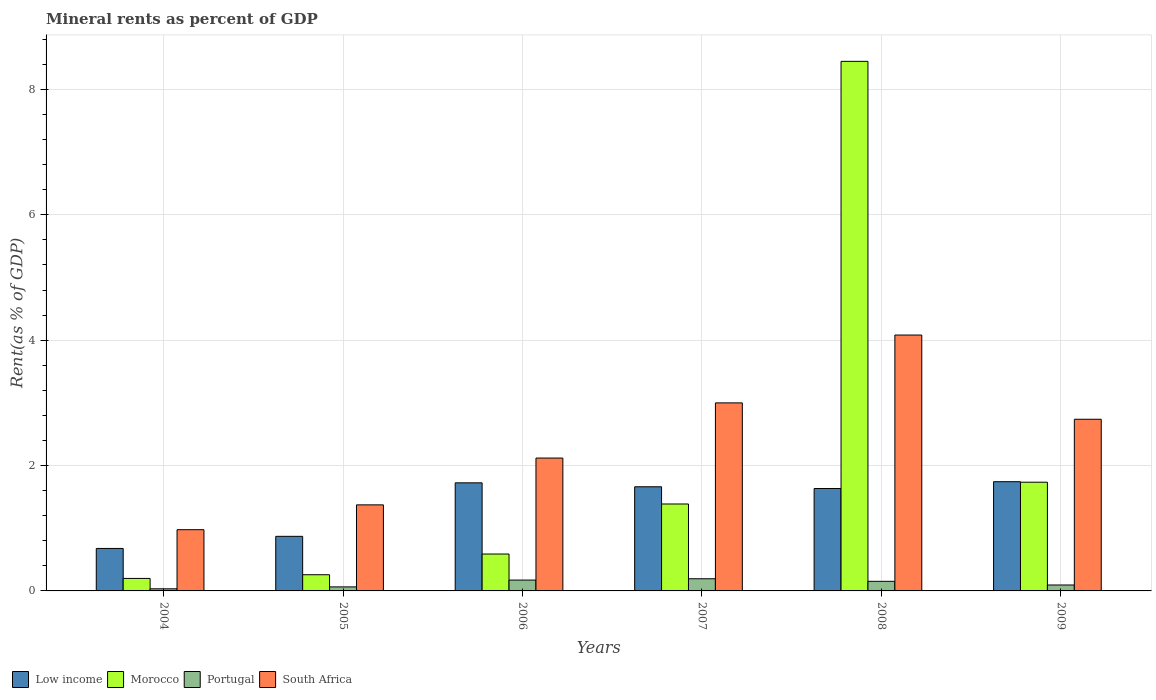How many different coloured bars are there?
Provide a short and direct response. 4. How many groups of bars are there?
Provide a short and direct response. 6. Are the number of bars per tick equal to the number of legend labels?
Offer a very short reply. Yes. What is the label of the 2nd group of bars from the left?
Offer a very short reply. 2005. What is the mineral rent in Portugal in 2004?
Ensure brevity in your answer.  0.03. Across all years, what is the maximum mineral rent in Portugal?
Give a very brief answer. 0.19. Across all years, what is the minimum mineral rent in Portugal?
Your response must be concise. 0.03. In which year was the mineral rent in Morocco minimum?
Provide a short and direct response. 2004. What is the total mineral rent in Portugal in the graph?
Your answer should be very brief. 0.71. What is the difference between the mineral rent in Morocco in 2004 and that in 2007?
Your response must be concise. -1.19. What is the difference between the mineral rent in Morocco in 2005 and the mineral rent in South Africa in 2004?
Offer a terse response. -0.72. What is the average mineral rent in Morocco per year?
Make the answer very short. 2.1. In the year 2009, what is the difference between the mineral rent in Low income and mineral rent in Portugal?
Your answer should be very brief. 1.65. In how many years, is the mineral rent in Portugal greater than 3.2 %?
Offer a very short reply. 0. What is the ratio of the mineral rent in Portugal in 2004 to that in 2008?
Ensure brevity in your answer.  0.22. Is the mineral rent in South Africa in 2004 less than that in 2005?
Make the answer very short. Yes. Is the difference between the mineral rent in Low income in 2007 and 2009 greater than the difference between the mineral rent in Portugal in 2007 and 2009?
Offer a very short reply. No. What is the difference between the highest and the second highest mineral rent in Portugal?
Provide a short and direct response. 0.02. What is the difference between the highest and the lowest mineral rent in Portugal?
Offer a very short reply. 0.16. Is the sum of the mineral rent in South Africa in 2004 and 2009 greater than the maximum mineral rent in Morocco across all years?
Your answer should be very brief. No. What does the 4th bar from the left in 2009 represents?
Your response must be concise. South Africa. What does the 2nd bar from the right in 2007 represents?
Your answer should be compact. Portugal. How many bars are there?
Provide a succinct answer. 24. What is the difference between two consecutive major ticks on the Y-axis?
Your response must be concise. 2. Are the values on the major ticks of Y-axis written in scientific E-notation?
Provide a succinct answer. No. Does the graph contain any zero values?
Your answer should be very brief. No. Does the graph contain grids?
Your response must be concise. Yes. What is the title of the graph?
Offer a terse response. Mineral rents as percent of GDP. Does "Middle income" appear as one of the legend labels in the graph?
Ensure brevity in your answer.  No. What is the label or title of the X-axis?
Offer a very short reply. Years. What is the label or title of the Y-axis?
Give a very brief answer. Rent(as % of GDP). What is the Rent(as % of GDP) in Low income in 2004?
Provide a succinct answer. 0.68. What is the Rent(as % of GDP) of Morocco in 2004?
Offer a terse response. 0.2. What is the Rent(as % of GDP) of Portugal in 2004?
Ensure brevity in your answer.  0.03. What is the Rent(as % of GDP) of South Africa in 2004?
Provide a short and direct response. 0.98. What is the Rent(as % of GDP) of Low income in 2005?
Your answer should be compact. 0.87. What is the Rent(as % of GDP) in Morocco in 2005?
Provide a short and direct response. 0.26. What is the Rent(as % of GDP) of Portugal in 2005?
Your response must be concise. 0.06. What is the Rent(as % of GDP) in South Africa in 2005?
Give a very brief answer. 1.37. What is the Rent(as % of GDP) of Low income in 2006?
Provide a succinct answer. 1.72. What is the Rent(as % of GDP) of Morocco in 2006?
Keep it short and to the point. 0.59. What is the Rent(as % of GDP) of Portugal in 2006?
Provide a succinct answer. 0.17. What is the Rent(as % of GDP) of South Africa in 2006?
Your answer should be very brief. 2.12. What is the Rent(as % of GDP) of Low income in 2007?
Offer a terse response. 1.66. What is the Rent(as % of GDP) in Morocco in 2007?
Keep it short and to the point. 1.39. What is the Rent(as % of GDP) of Portugal in 2007?
Offer a very short reply. 0.19. What is the Rent(as % of GDP) in South Africa in 2007?
Your answer should be compact. 3. What is the Rent(as % of GDP) in Low income in 2008?
Your answer should be compact. 1.63. What is the Rent(as % of GDP) in Morocco in 2008?
Provide a succinct answer. 8.45. What is the Rent(as % of GDP) of Portugal in 2008?
Offer a very short reply. 0.15. What is the Rent(as % of GDP) in South Africa in 2008?
Offer a very short reply. 4.08. What is the Rent(as % of GDP) of Low income in 2009?
Make the answer very short. 1.74. What is the Rent(as % of GDP) in Morocco in 2009?
Your answer should be very brief. 1.73. What is the Rent(as % of GDP) in Portugal in 2009?
Keep it short and to the point. 0.09. What is the Rent(as % of GDP) of South Africa in 2009?
Keep it short and to the point. 2.74. Across all years, what is the maximum Rent(as % of GDP) of Low income?
Offer a very short reply. 1.74. Across all years, what is the maximum Rent(as % of GDP) of Morocco?
Give a very brief answer. 8.45. Across all years, what is the maximum Rent(as % of GDP) in Portugal?
Offer a terse response. 0.19. Across all years, what is the maximum Rent(as % of GDP) of South Africa?
Keep it short and to the point. 4.08. Across all years, what is the minimum Rent(as % of GDP) of Low income?
Provide a succinct answer. 0.68. Across all years, what is the minimum Rent(as % of GDP) of Morocco?
Offer a very short reply. 0.2. Across all years, what is the minimum Rent(as % of GDP) in Portugal?
Make the answer very short. 0.03. Across all years, what is the minimum Rent(as % of GDP) in South Africa?
Offer a terse response. 0.98. What is the total Rent(as % of GDP) of Low income in the graph?
Keep it short and to the point. 8.31. What is the total Rent(as % of GDP) in Morocco in the graph?
Keep it short and to the point. 12.62. What is the total Rent(as % of GDP) in Portugal in the graph?
Provide a succinct answer. 0.71. What is the total Rent(as % of GDP) in South Africa in the graph?
Give a very brief answer. 14.29. What is the difference between the Rent(as % of GDP) in Low income in 2004 and that in 2005?
Provide a short and direct response. -0.19. What is the difference between the Rent(as % of GDP) of Morocco in 2004 and that in 2005?
Your answer should be very brief. -0.06. What is the difference between the Rent(as % of GDP) of Portugal in 2004 and that in 2005?
Make the answer very short. -0.03. What is the difference between the Rent(as % of GDP) of South Africa in 2004 and that in 2005?
Make the answer very short. -0.4. What is the difference between the Rent(as % of GDP) of Low income in 2004 and that in 2006?
Offer a very short reply. -1.05. What is the difference between the Rent(as % of GDP) in Morocco in 2004 and that in 2006?
Ensure brevity in your answer.  -0.39. What is the difference between the Rent(as % of GDP) in Portugal in 2004 and that in 2006?
Make the answer very short. -0.14. What is the difference between the Rent(as % of GDP) in South Africa in 2004 and that in 2006?
Your answer should be compact. -1.14. What is the difference between the Rent(as % of GDP) in Low income in 2004 and that in 2007?
Make the answer very short. -0.98. What is the difference between the Rent(as % of GDP) of Morocco in 2004 and that in 2007?
Offer a terse response. -1.19. What is the difference between the Rent(as % of GDP) of Portugal in 2004 and that in 2007?
Provide a short and direct response. -0.16. What is the difference between the Rent(as % of GDP) of South Africa in 2004 and that in 2007?
Your answer should be very brief. -2.02. What is the difference between the Rent(as % of GDP) in Low income in 2004 and that in 2008?
Offer a very short reply. -0.96. What is the difference between the Rent(as % of GDP) in Morocco in 2004 and that in 2008?
Offer a very short reply. -8.25. What is the difference between the Rent(as % of GDP) in Portugal in 2004 and that in 2008?
Give a very brief answer. -0.12. What is the difference between the Rent(as % of GDP) of South Africa in 2004 and that in 2008?
Make the answer very short. -3.11. What is the difference between the Rent(as % of GDP) of Low income in 2004 and that in 2009?
Your answer should be compact. -1.06. What is the difference between the Rent(as % of GDP) in Morocco in 2004 and that in 2009?
Offer a terse response. -1.54. What is the difference between the Rent(as % of GDP) of Portugal in 2004 and that in 2009?
Your answer should be compact. -0.06. What is the difference between the Rent(as % of GDP) of South Africa in 2004 and that in 2009?
Your answer should be compact. -1.76. What is the difference between the Rent(as % of GDP) in Low income in 2005 and that in 2006?
Make the answer very short. -0.85. What is the difference between the Rent(as % of GDP) in Morocco in 2005 and that in 2006?
Your answer should be very brief. -0.33. What is the difference between the Rent(as % of GDP) in Portugal in 2005 and that in 2006?
Keep it short and to the point. -0.11. What is the difference between the Rent(as % of GDP) in South Africa in 2005 and that in 2006?
Provide a short and direct response. -0.75. What is the difference between the Rent(as % of GDP) of Low income in 2005 and that in 2007?
Provide a short and direct response. -0.79. What is the difference between the Rent(as % of GDP) of Morocco in 2005 and that in 2007?
Your answer should be compact. -1.13. What is the difference between the Rent(as % of GDP) in Portugal in 2005 and that in 2007?
Your response must be concise. -0.13. What is the difference between the Rent(as % of GDP) in South Africa in 2005 and that in 2007?
Offer a very short reply. -1.63. What is the difference between the Rent(as % of GDP) in Low income in 2005 and that in 2008?
Provide a short and direct response. -0.76. What is the difference between the Rent(as % of GDP) of Morocco in 2005 and that in 2008?
Keep it short and to the point. -8.19. What is the difference between the Rent(as % of GDP) in Portugal in 2005 and that in 2008?
Offer a terse response. -0.09. What is the difference between the Rent(as % of GDP) in South Africa in 2005 and that in 2008?
Your response must be concise. -2.71. What is the difference between the Rent(as % of GDP) of Low income in 2005 and that in 2009?
Offer a very short reply. -0.87. What is the difference between the Rent(as % of GDP) in Morocco in 2005 and that in 2009?
Make the answer very short. -1.48. What is the difference between the Rent(as % of GDP) of Portugal in 2005 and that in 2009?
Ensure brevity in your answer.  -0.03. What is the difference between the Rent(as % of GDP) in South Africa in 2005 and that in 2009?
Give a very brief answer. -1.37. What is the difference between the Rent(as % of GDP) in Low income in 2006 and that in 2007?
Your answer should be compact. 0.06. What is the difference between the Rent(as % of GDP) of Morocco in 2006 and that in 2007?
Give a very brief answer. -0.8. What is the difference between the Rent(as % of GDP) of Portugal in 2006 and that in 2007?
Your response must be concise. -0.02. What is the difference between the Rent(as % of GDP) of South Africa in 2006 and that in 2007?
Ensure brevity in your answer.  -0.88. What is the difference between the Rent(as % of GDP) in Low income in 2006 and that in 2008?
Provide a short and direct response. 0.09. What is the difference between the Rent(as % of GDP) of Morocco in 2006 and that in 2008?
Make the answer very short. -7.86. What is the difference between the Rent(as % of GDP) of Portugal in 2006 and that in 2008?
Provide a short and direct response. 0.02. What is the difference between the Rent(as % of GDP) in South Africa in 2006 and that in 2008?
Your response must be concise. -1.96. What is the difference between the Rent(as % of GDP) in Low income in 2006 and that in 2009?
Give a very brief answer. -0.02. What is the difference between the Rent(as % of GDP) in Morocco in 2006 and that in 2009?
Offer a very short reply. -1.15. What is the difference between the Rent(as % of GDP) in Portugal in 2006 and that in 2009?
Keep it short and to the point. 0.08. What is the difference between the Rent(as % of GDP) of South Africa in 2006 and that in 2009?
Give a very brief answer. -0.62. What is the difference between the Rent(as % of GDP) of Low income in 2007 and that in 2008?
Keep it short and to the point. 0.03. What is the difference between the Rent(as % of GDP) of Morocco in 2007 and that in 2008?
Your response must be concise. -7.06. What is the difference between the Rent(as % of GDP) of Portugal in 2007 and that in 2008?
Provide a succinct answer. 0.04. What is the difference between the Rent(as % of GDP) in South Africa in 2007 and that in 2008?
Offer a very short reply. -1.08. What is the difference between the Rent(as % of GDP) of Low income in 2007 and that in 2009?
Ensure brevity in your answer.  -0.08. What is the difference between the Rent(as % of GDP) in Morocco in 2007 and that in 2009?
Your answer should be very brief. -0.35. What is the difference between the Rent(as % of GDP) of Portugal in 2007 and that in 2009?
Ensure brevity in your answer.  0.1. What is the difference between the Rent(as % of GDP) in South Africa in 2007 and that in 2009?
Your response must be concise. 0.26. What is the difference between the Rent(as % of GDP) of Low income in 2008 and that in 2009?
Your response must be concise. -0.11. What is the difference between the Rent(as % of GDP) in Morocco in 2008 and that in 2009?
Your answer should be very brief. 6.71. What is the difference between the Rent(as % of GDP) in Portugal in 2008 and that in 2009?
Provide a short and direct response. 0.06. What is the difference between the Rent(as % of GDP) in South Africa in 2008 and that in 2009?
Give a very brief answer. 1.34. What is the difference between the Rent(as % of GDP) of Low income in 2004 and the Rent(as % of GDP) of Morocco in 2005?
Provide a short and direct response. 0.42. What is the difference between the Rent(as % of GDP) in Low income in 2004 and the Rent(as % of GDP) in Portugal in 2005?
Give a very brief answer. 0.61. What is the difference between the Rent(as % of GDP) in Low income in 2004 and the Rent(as % of GDP) in South Africa in 2005?
Ensure brevity in your answer.  -0.7. What is the difference between the Rent(as % of GDP) in Morocco in 2004 and the Rent(as % of GDP) in Portugal in 2005?
Keep it short and to the point. 0.14. What is the difference between the Rent(as % of GDP) in Morocco in 2004 and the Rent(as % of GDP) in South Africa in 2005?
Keep it short and to the point. -1.17. What is the difference between the Rent(as % of GDP) in Portugal in 2004 and the Rent(as % of GDP) in South Africa in 2005?
Ensure brevity in your answer.  -1.34. What is the difference between the Rent(as % of GDP) of Low income in 2004 and the Rent(as % of GDP) of Morocco in 2006?
Provide a short and direct response. 0.09. What is the difference between the Rent(as % of GDP) in Low income in 2004 and the Rent(as % of GDP) in Portugal in 2006?
Keep it short and to the point. 0.5. What is the difference between the Rent(as % of GDP) in Low income in 2004 and the Rent(as % of GDP) in South Africa in 2006?
Your answer should be compact. -1.44. What is the difference between the Rent(as % of GDP) in Morocco in 2004 and the Rent(as % of GDP) in Portugal in 2006?
Your answer should be very brief. 0.03. What is the difference between the Rent(as % of GDP) of Morocco in 2004 and the Rent(as % of GDP) of South Africa in 2006?
Provide a short and direct response. -1.92. What is the difference between the Rent(as % of GDP) of Portugal in 2004 and the Rent(as % of GDP) of South Africa in 2006?
Your response must be concise. -2.09. What is the difference between the Rent(as % of GDP) in Low income in 2004 and the Rent(as % of GDP) in Morocco in 2007?
Make the answer very short. -0.71. What is the difference between the Rent(as % of GDP) in Low income in 2004 and the Rent(as % of GDP) in Portugal in 2007?
Keep it short and to the point. 0.48. What is the difference between the Rent(as % of GDP) of Low income in 2004 and the Rent(as % of GDP) of South Africa in 2007?
Give a very brief answer. -2.32. What is the difference between the Rent(as % of GDP) of Morocco in 2004 and the Rent(as % of GDP) of Portugal in 2007?
Ensure brevity in your answer.  0.01. What is the difference between the Rent(as % of GDP) of Morocco in 2004 and the Rent(as % of GDP) of South Africa in 2007?
Make the answer very short. -2.8. What is the difference between the Rent(as % of GDP) in Portugal in 2004 and the Rent(as % of GDP) in South Africa in 2007?
Offer a terse response. -2.97. What is the difference between the Rent(as % of GDP) of Low income in 2004 and the Rent(as % of GDP) of Morocco in 2008?
Offer a very short reply. -7.77. What is the difference between the Rent(as % of GDP) of Low income in 2004 and the Rent(as % of GDP) of Portugal in 2008?
Ensure brevity in your answer.  0.52. What is the difference between the Rent(as % of GDP) of Low income in 2004 and the Rent(as % of GDP) of South Africa in 2008?
Make the answer very short. -3.4. What is the difference between the Rent(as % of GDP) in Morocco in 2004 and the Rent(as % of GDP) in Portugal in 2008?
Your response must be concise. 0.05. What is the difference between the Rent(as % of GDP) in Morocco in 2004 and the Rent(as % of GDP) in South Africa in 2008?
Offer a very short reply. -3.88. What is the difference between the Rent(as % of GDP) of Portugal in 2004 and the Rent(as % of GDP) of South Africa in 2008?
Ensure brevity in your answer.  -4.05. What is the difference between the Rent(as % of GDP) in Low income in 2004 and the Rent(as % of GDP) in Morocco in 2009?
Your response must be concise. -1.06. What is the difference between the Rent(as % of GDP) in Low income in 2004 and the Rent(as % of GDP) in Portugal in 2009?
Provide a succinct answer. 0.58. What is the difference between the Rent(as % of GDP) of Low income in 2004 and the Rent(as % of GDP) of South Africa in 2009?
Ensure brevity in your answer.  -2.06. What is the difference between the Rent(as % of GDP) in Morocco in 2004 and the Rent(as % of GDP) in Portugal in 2009?
Provide a short and direct response. 0.1. What is the difference between the Rent(as % of GDP) in Morocco in 2004 and the Rent(as % of GDP) in South Africa in 2009?
Give a very brief answer. -2.54. What is the difference between the Rent(as % of GDP) in Portugal in 2004 and the Rent(as % of GDP) in South Africa in 2009?
Provide a short and direct response. -2.71. What is the difference between the Rent(as % of GDP) in Low income in 2005 and the Rent(as % of GDP) in Morocco in 2006?
Make the answer very short. 0.28. What is the difference between the Rent(as % of GDP) in Low income in 2005 and the Rent(as % of GDP) in Portugal in 2006?
Offer a very short reply. 0.7. What is the difference between the Rent(as % of GDP) in Low income in 2005 and the Rent(as % of GDP) in South Africa in 2006?
Give a very brief answer. -1.25. What is the difference between the Rent(as % of GDP) in Morocco in 2005 and the Rent(as % of GDP) in Portugal in 2006?
Provide a short and direct response. 0.09. What is the difference between the Rent(as % of GDP) in Morocco in 2005 and the Rent(as % of GDP) in South Africa in 2006?
Your response must be concise. -1.86. What is the difference between the Rent(as % of GDP) in Portugal in 2005 and the Rent(as % of GDP) in South Africa in 2006?
Give a very brief answer. -2.06. What is the difference between the Rent(as % of GDP) of Low income in 2005 and the Rent(as % of GDP) of Morocco in 2007?
Give a very brief answer. -0.52. What is the difference between the Rent(as % of GDP) in Low income in 2005 and the Rent(as % of GDP) in Portugal in 2007?
Provide a short and direct response. 0.68. What is the difference between the Rent(as % of GDP) of Low income in 2005 and the Rent(as % of GDP) of South Africa in 2007?
Your response must be concise. -2.13. What is the difference between the Rent(as % of GDP) of Morocco in 2005 and the Rent(as % of GDP) of Portugal in 2007?
Provide a succinct answer. 0.06. What is the difference between the Rent(as % of GDP) in Morocco in 2005 and the Rent(as % of GDP) in South Africa in 2007?
Offer a terse response. -2.74. What is the difference between the Rent(as % of GDP) in Portugal in 2005 and the Rent(as % of GDP) in South Africa in 2007?
Ensure brevity in your answer.  -2.94. What is the difference between the Rent(as % of GDP) in Low income in 2005 and the Rent(as % of GDP) in Morocco in 2008?
Your response must be concise. -7.58. What is the difference between the Rent(as % of GDP) of Low income in 2005 and the Rent(as % of GDP) of Portugal in 2008?
Provide a succinct answer. 0.72. What is the difference between the Rent(as % of GDP) of Low income in 2005 and the Rent(as % of GDP) of South Africa in 2008?
Your answer should be compact. -3.21. What is the difference between the Rent(as % of GDP) of Morocco in 2005 and the Rent(as % of GDP) of Portugal in 2008?
Give a very brief answer. 0.11. What is the difference between the Rent(as % of GDP) of Morocco in 2005 and the Rent(as % of GDP) of South Africa in 2008?
Offer a very short reply. -3.82. What is the difference between the Rent(as % of GDP) in Portugal in 2005 and the Rent(as % of GDP) in South Africa in 2008?
Keep it short and to the point. -4.02. What is the difference between the Rent(as % of GDP) in Low income in 2005 and the Rent(as % of GDP) in Morocco in 2009?
Keep it short and to the point. -0.86. What is the difference between the Rent(as % of GDP) of Low income in 2005 and the Rent(as % of GDP) of Portugal in 2009?
Offer a terse response. 0.78. What is the difference between the Rent(as % of GDP) of Low income in 2005 and the Rent(as % of GDP) of South Africa in 2009?
Offer a very short reply. -1.87. What is the difference between the Rent(as % of GDP) in Morocco in 2005 and the Rent(as % of GDP) in Portugal in 2009?
Provide a short and direct response. 0.16. What is the difference between the Rent(as % of GDP) in Morocco in 2005 and the Rent(as % of GDP) in South Africa in 2009?
Offer a terse response. -2.48. What is the difference between the Rent(as % of GDP) in Portugal in 2005 and the Rent(as % of GDP) in South Africa in 2009?
Provide a short and direct response. -2.67. What is the difference between the Rent(as % of GDP) of Low income in 2006 and the Rent(as % of GDP) of Morocco in 2007?
Give a very brief answer. 0.34. What is the difference between the Rent(as % of GDP) in Low income in 2006 and the Rent(as % of GDP) in Portugal in 2007?
Provide a short and direct response. 1.53. What is the difference between the Rent(as % of GDP) in Low income in 2006 and the Rent(as % of GDP) in South Africa in 2007?
Your answer should be very brief. -1.28. What is the difference between the Rent(as % of GDP) in Morocco in 2006 and the Rent(as % of GDP) in Portugal in 2007?
Your answer should be very brief. 0.39. What is the difference between the Rent(as % of GDP) in Morocco in 2006 and the Rent(as % of GDP) in South Africa in 2007?
Your response must be concise. -2.41. What is the difference between the Rent(as % of GDP) of Portugal in 2006 and the Rent(as % of GDP) of South Africa in 2007?
Your answer should be compact. -2.83. What is the difference between the Rent(as % of GDP) of Low income in 2006 and the Rent(as % of GDP) of Morocco in 2008?
Your answer should be compact. -6.72. What is the difference between the Rent(as % of GDP) in Low income in 2006 and the Rent(as % of GDP) in Portugal in 2008?
Your answer should be compact. 1.57. What is the difference between the Rent(as % of GDP) of Low income in 2006 and the Rent(as % of GDP) of South Africa in 2008?
Ensure brevity in your answer.  -2.36. What is the difference between the Rent(as % of GDP) of Morocco in 2006 and the Rent(as % of GDP) of Portugal in 2008?
Offer a very short reply. 0.44. What is the difference between the Rent(as % of GDP) of Morocco in 2006 and the Rent(as % of GDP) of South Africa in 2008?
Your answer should be very brief. -3.49. What is the difference between the Rent(as % of GDP) of Portugal in 2006 and the Rent(as % of GDP) of South Africa in 2008?
Give a very brief answer. -3.91. What is the difference between the Rent(as % of GDP) of Low income in 2006 and the Rent(as % of GDP) of Morocco in 2009?
Give a very brief answer. -0.01. What is the difference between the Rent(as % of GDP) in Low income in 2006 and the Rent(as % of GDP) in Portugal in 2009?
Give a very brief answer. 1.63. What is the difference between the Rent(as % of GDP) in Low income in 2006 and the Rent(as % of GDP) in South Africa in 2009?
Provide a short and direct response. -1.01. What is the difference between the Rent(as % of GDP) in Morocco in 2006 and the Rent(as % of GDP) in Portugal in 2009?
Offer a terse response. 0.49. What is the difference between the Rent(as % of GDP) of Morocco in 2006 and the Rent(as % of GDP) of South Africa in 2009?
Provide a short and direct response. -2.15. What is the difference between the Rent(as % of GDP) in Portugal in 2006 and the Rent(as % of GDP) in South Africa in 2009?
Your response must be concise. -2.57. What is the difference between the Rent(as % of GDP) in Low income in 2007 and the Rent(as % of GDP) in Morocco in 2008?
Give a very brief answer. -6.79. What is the difference between the Rent(as % of GDP) of Low income in 2007 and the Rent(as % of GDP) of Portugal in 2008?
Offer a very short reply. 1.51. What is the difference between the Rent(as % of GDP) in Low income in 2007 and the Rent(as % of GDP) in South Africa in 2008?
Offer a terse response. -2.42. What is the difference between the Rent(as % of GDP) of Morocco in 2007 and the Rent(as % of GDP) of Portugal in 2008?
Make the answer very short. 1.23. What is the difference between the Rent(as % of GDP) in Morocco in 2007 and the Rent(as % of GDP) in South Africa in 2008?
Offer a very short reply. -2.7. What is the difference between the Rent(as % of GDP) of Portugal in 2007 and the Rent(as % of GDP) of South Africa in 2008?
Your response must be concise. -3.89. What is the difference between the Rent(as % of GDP) of Low income in 2007 and the Rent(as % of GDP) of Morocco in 2009?
Your answer should be very brief. -0.07. What is the difference between the Rent(as % of GDP) of Low income in 2007 and the Rent(as % of GDP) of Portugal in 2009?
Your answer should be compact. 1.57. What is the difference between the Rent(as % of GDP) in Low income in 2007 and the Rent(as % of GDP) in South Africa in 2009?
Offer a terse response. -1.08. What is the difference between the Rent(as % of GDP) of Morocco in 2007 and the Rent(as % of GDP) of Portugal in 2009?
Offer a very short reply. 1.29. What is the difference between the Rent(as % of GDP) of Morocco in 2007 and the Rent(as % of GDP) of South Africa in 2009?
Ensure brevity in your answer.  -1.35. What is the difference between the Rent(as % of GDP) of Portugal in 2007 and the Rent(as % of GDP) of South Africa in 2009?
Your response must be concise. -2.54. What is the difference between the Rent(as % of GDP) in Low income in 2008 and the Rent(as % of GDP) in Morocco in 2009?
Offer a very short reply. -0.1. What is the difference between the Rent(as % of GDP) of Low income in 2008 and the Rent(as % of GDP) of Portugal in 2009?
Provide a short and direct response. 1.54. What is the difference between the Rent(as % of GDP) in Low income in 2008 and the Rent(as % of GDP) in South Africa in 2009?
Make the answer very short. -1.11. What is the difference between the Rent(as % of GDP) in Morocco in 2008 and the Rent(as % of GDP) in Portugal in 2009?
Your answer should be very brief. 8.35. What is the difference between the Rent(as % of GDP) in Morocco in 2008 and the Rent(as % of GDP) in South Africa in 2009?
Provide a succinct answer. 5.71. What is the difference between the Rent(as % of GDP) in Portugal in 2008 and the Rent(as % of GDP) in South Africa in 2009?
Offer a terse response. -2.59. What is the average Rent(as % of GDP) of Low income per year?
Your response must be concise. 1.39. What is the average Rent(as % of GDP) in Morocco per year?
Keep it short and to the point. 2.1. What is the average Rent(as % of GDP) in Portugal per year?
Keep it short and to the point. 0.12. What is the average Rent(as % of GDP) in South Africa per year?
Your answer should be very brief. 2.38. In the year 2004, what is the difference between the Rent(as % of GDP) in Low income and Rent(as % of GDP) in Morocco?
Provide a succinct answer. 0.48. In the year 2004, what is the difference between the Rent(as % of GDP) in Low income and Rent(as % of GDP) in Portugal?
Give a very brief answer. 0.64. In the year 2004, what is the difference between the Rent(as % of GDP) in Low income and Rent(as % of GDP) in South Africa?
Give a very brief answer. -0.3. In the year 2004, what is the difference between the Rent(as % of GDP) in Morocco and Rent(as % of GDP) in Portugal?
Your response must be concise. 0.17. In the year 2004, what is the difference between the Rent(as % of GDP) of Morocco and Rent(as % of GDP) of South Africa?
Provide a succinct answer. -0.78. In the year 2004, what is the difference between the Rent(as % of GDP) of Portugal and Rent(as % of GDP) of South Africa?
Provide a short and direct response. -0.94. In the year 2005, what is the difference between the Rent(as % of GDP) in Low income and Rent(as % of GDP) in Morocco?
Your response must be concise. 0.61. In the year 2005, what is the difference between the Rent(as % of GDP) of Low income and Rent(as % of GDP) of Portugal?
Give a very brief answer. 0.81. In the year 2005, what is the difference between the Rent(as % of GDP) of Low income and Rent(as % of GDP) of South Africa?
Offer a very short reply. -0.5. In the year 2005, what is the difference between the Rent(as % of GDP) of Morocco and Rent(as % of GDP) of Portugal?
Ensure brevity in your answer.  0.19. In the year 2005, what is the difference between the Rent(as % of GDP) in Morocco and Rent(as % of GDP) in South Africa?
Make the answer very short. -1.11. In the year 2005, what is the difference between the Rent(as % of GDP) in Portugal and Rent(as % of GDP) in South Africa?
Keep it short and to the point. -1.31. In the year 2006, what is the difference between the Rent(as % of GDP) of Low income and Rent(as % of GDP) of Morocco?
Offer a terse response. 1.14. In the year 2006, what is the difference between the Rent(as % of GDP) in Low income and Rent(as % of GDP) in Portugal?
Offer a terse response. 1.55. In the year 2006, what is the difference between the Rent(as % of GDP) in Low income and Rent(as % of GDP) in South Africa?
Your answer should be very brief. -0.4. In the year 2006, what is the difference between the Rent(as % of GDP) in Morocco and Rent(as % of GDP) in Portugal?
Make the answer very short. 0.42. In the year 2006, what is the difference between the Rent(as % of GDP) of Morocco and Rent(as % of GDP) of South Africa?
Offer a terse response. -1.53. In the year 2006, what is the difference between the Rent(as % of GDP) in Portugal and Rent(as % of GDP) in South Africa?
Offer a terse response. -1.95. In the year 2007, what is the difference between the Rent(as % of GDP) in Low income and Rent(as % of GDP) in Morocco?
Your answer should be very brief. 0.27. In the year 2007, what is the difference between the Rent(as % of GDP) of Low income and Rent(as % of GDP) of Portugal?
Your answer should be compact. 1.47. In the year 2007, what is the difference between the Rent(as % of GDP) of Low income and Rent(as % of GDP) of South Africa?
Your response must be concise. -1.34. In the year 2007, what is the difference between the Rent(as % of GDP) of Morocco and Rent(as % of GDP) of Portugal?
Your answer should be compact. 1.19. In the year 2007, what is the difference between the Rent(as % of GDP) of Morocco and Rent(as % of GDP) of South Africa?
Provide a short and direct response. -1.61. In the year 2007, what is the difference between the Rent(as % of GDP) of Portugal and Rent(as % of GDP) of South Africa?
Ensure brevity in your answer.  -2.81. In the year 2008, what is the difference between the Rent(as % of GDP) of Low income and Rent(as % of GDP) of Morocco?
Your response must be concise. -6.82. In the year 2008, what is the difference between the Rent(as % of GDP) of Low income and Rent(as % of GDP) of Portugal?
Provide a succinct answer. 1.48. In the year 2008, what is the difference between the Rent(as % of GDP) in Low income and Rent(as % of GDP) in South Africa?
Ensure brevity in your answer.  -2.45. In the year 2008, what is the difference between the Rent(as % of GDP) in Morocco and Rent(as % of GDP) in Portugal?
Offer a terse response. 8.3. In the year 2008, what is the difference between the Rent(as % of GDP) of Morocco and Rent(as % of GDP) of South Africa?
Provide a short and direct response. 4.37. In the year 2008, what is the difference between the Rent(as % of GDP) of Portugal and Rent(as % of GDP) of South Africa?
Ensure brevity in your answer.  -3.93. In the year 2009, what is the difference between the Rent(as % of GDP) in Low income and Rent(as % of GDP) in Morocco?
Give a very brief answer. 0.01. In the year 2009, what is the difference between the Rent(as % of GDP) in Low income and Rent(as % of GDP) in Portugal?
Provide a short and direct response. 1.65. In the year 2009, what is the difference between the Rent(as % of GDP) of Low income and Rent(as % of GDP) of South Africa?
Your answer should be very brief. -1. In the year 2009, what is the difference between the Rent(as % of GDP) in Morocco and Rent(as % of GDP) in Portugal?
Your answer should be very brief. 1.64. In the year 2009, what is the difference between the Rent(as % of GDP) of Morocco and Rent(as % of GDP) of South Africa?
Provide a succinct answer. -1. In the year 2009, what is the difference between the Rent(as % of GDP) in Portugal and Rent(as % of GDP) in South Africa?
Offer a terse response. -2.64. What is the ratio of the Rent(as % of GDP) in Low income in 2004 to that in 2005?
Offer a very short reply. 0.78. What is the ratio of the Rent(as % of GDP) in Morocco in 2004 to that in 2005?
Offer a terse response. 0.77. What is the ratio of the Rent(as % of GDP) in Portugal in 2004 to that in 2005?
Offer a terse response. 0.53. What is the ratio of the Rent(as % of GDP) in South Africa in 2004 to that in 2005?
Offer a terse response. 0.71. What is the ratio of the Rent(as % of GDP) in Low income in 2004 to that in 2006?
Your answer should be very brief. 0.39. What is the ratio of the Rent(as % of GDP) of Morocco in 2004 to that in 2006?
Your answer should be compact. 0.34. What is the ratio of the Rent(as % of GDP) of Portugal in 2004 to that in 2006?
Provide a succinct answer. 0.2. What is the ratio of the Rent(as % of GDP) of South Africa in 2004 to that in 2006?
Give a very brief answer. 0.46. What is the ratio of the Rent(as % of GDP) of Low income in 2004 to that in 2007?
Give a very brief answer. 0.41. What is the ratio of the Rent(as % of GDP) in Morocco in 2004 to that in 2007?
Provide a short and direct response. 0.14. What is the ratio of the Rent(as % of GDP) of Portugal in 2004 to that in 2007?
Your response must be concise. 0.17. What is the ratio of the Rent(as % of GDP) in South Africa in 2004 to that in 2007?
Provide a short and direct response. 0.33. What is the ratio of the Rent(as % of GDP) in Low income in 2004 to that in 2008?
Your answer should be compact. 0.41. What is the ratio of the Rent(as % of GDP) of Morocco in 2004 to that in 2008?
Offer a terse response. 0.02. What is the ratio of the Rent(as % of GDP) of Portugal in 2004 to that in 2008?
Give a very brief answer. 0.22. What is the ratio of the Rent(as % of GDP) in South Africa in 2004 to that in 2008?
Offer a terse response. 0.24. What is the ratio of the Rent(as % of GDP) in Low income in 2004 to that in 2009?
Keep it short and to the point. 0.39. What is the ratio of the Rent(as % of GDP) of Morocco in 2004 to that in 2009?
Provide a succinct answer. 0.11. What is the ratio of the Rent(as % of GDP) of Portugal in 2004 to that in 2009?
Offer a very short reply. 0.36. What is the ratio of the Rent(as % of GDP) in South Africa in 2004 to that in 2009?
Offer a very short reply. 0.36. What is the ratio of the Rent(as % of GDP) of Low income in 2005 to that in 2006?
Provide a succinct answer. 0.51. What is the ratio of the Rent(as % of GDP) in Morocco in 2005 to that in 2006?
Provide a short and direct response. 0.44. What is the ratio of the Rent(as % of GDP) of Portugal in 2005 to that in 2006?
Your answer should be very brief. 0.37. What is the ratio of the Rent(as % of GDP) in South Africa in 2005 to that in 2006?
Make the answer very short. 0.65. What is the ratio of the Rent(as % of GDP) of Low income in 2005 to that in 2007?
Give a very brief answer. 0.52. What is the ratio of the Rent(as % of GDP) in Morocco in 2005 to that in 2007?
Provide a short and direct response. 0.19. What is the ratio of the Rent(as % of GDP) in Portugal in 2005 to that in 2007?
Your response must be concise. 0.33. What is the ratio of the Rent(as % of GDP) of South Africa in 2005 to that in 2007?
Offer a terse response. 0.46. What is the ratio of the Rent(as % of GDP) of Low income in 2005 to that in 2008?
Make the answer very short. 0.53. What is the ratio of the Rent(as % of GDP) in Morocco in 2005 to that in 2008?
Your response must be concise. 0.03. What is the ratio of the Rent(as % of GDP) in Portugal in 2005 to that in 2008?
Your answer should be compact. 0.42. What is the ratio of the Rent(as % of GDP) of South Africa in 2005 to that in 2008?
Your answer should be compact. 0.34. What is the ratio of the Rent(as % of GDP) of Low income in 2005 to that in 2009?
Make the answer very short. 0.5. What is the ratio of the Rent(as % of GDP) of Morocco in 2005 to that in 2009?
Your answer should be very brief. 0.15. What is the ratio of the Rent(as % of GDP) in Portugal in 2005 to that in 2009?
Keep it short and to the point. 0.68. What is the ratio of the Rent(as % of GDP) of South Africa in 2005 to that in 2009?
Ensure brevity in your answer.  0.5. What is the ratio of the Rent(as % of GDP) in Low income in 2006 to that in 2007?
Make the answer very short. 1.04. What is the ratio of the Rent(as % of GDP) of Morocco in 2006 to that in 2007?
Keep it short and to the point. 0.42. What is the ratio of the Rent(as % of GDP) of Portugal in 2006 to that in 2007?
Make the answer very short. 0.89. What is the ratio of the Rent(as % of GDP) of South Africa in 2006 to that in 2007?
Give a very brief answer. 0.71. What is the ratio of the Rent(as % of GDP) in Low income in 2006 to that in 2008?
Offer a terse response. 1.06. What is the ratio of the Rent(as % of GDP) of Morocco in 2006 to that in 2008?
Make the answer very short. 0.07. What is the ratio of the Rent(as % of GDP) of Portugal in 2006 to that in 2008?
Keep it short and to the point. 1.13. What is the ratio of the Rent(as % of GDP) in South Africa in 2006 to that in 2008?
Offer a very short reply. 0.52. What is the ratio of the Rent(as % of GDP) in Low income in 2006 to that in 2009?
Provide a succinct answer. 0.99. What is the ratio of the Rent(as % of GDP) of Morocco in 2006 to that in 2009?
Give a very brief answer. 0.34. What is the ratio of the Rent(as % of GDP) of Portugal in 2006 to that in 2009?
Make the answer very short. 1.83. What is the ratio of the Rent(as % of GDP) in South Africa in 2006 to that in 2009?
Give a very brief answer. 0.77. What is the ratio of the Rent(as % of GDP) of Low income in 2007 to that in 2008?
Offer a very short reply. 1.02. What is the ratio of the Rent(as % of GDP) of Morocco in 2007 to that in 2008?
Your response must be concise. 0.16. What is the ratio of the Rent(as % of GDP) in Portugal in 2007 to that in 2008?
Your response must be concise. 1.27. What is the ratio of the Rent(as % of GDP) of South Africa in 2007 to that in 2008?
Offer a terse response. 0.73. What is the ratio of the Rent(as % of GDP) in Low income in 2007 to that in 2009?
Your response must be concise. 0.95. What is the ratio of the Rent(as % of GDP) in Morocco in 2007 to that in 2009?
Keep it short and to the point. 0.8. What is the ratio of the Rent(as % of GDP) of Portugal in 2007 to that in 2009?
Give a very brief answer. 2.05. What is the ratio of the Rent(as % of GDP) of South Africa in 2007 to that in 2009?
Ensure brevity in your answer.  1.1. What is the ratio of the Rent(as % of GDP) in Morocco in 2008 to that in 2009?
Keep it short and to the point. 4.87. What is the ratio of the Rent(as % of GDP) of Portugal in 2008 to that in 2009?
Your answer should be very brief. 1.62. What is the ratio of the Rent(as % of GDP) of South Africa in 2008 to that in 2009?
Offer a terse response. 1.49. What is the difference between the highest and the second highest Rent(as % of GDP) in Low income?
Give a very brief answer. 0.02. What is the difference between the highest and the second highest Rent(as % of GDP) of Morocco?
Offer a very short reply. 6.71. What is the difference between the highest and the second highest Rent(as % of GDP) in Portugal?
Your response must be concise. 0.02. What is the difference between the highest and the second highest Rent(as % of GDP) in South Africa?
Your answer should be very brief. 1.08. What is the difference between the highest and the lowest Rent(as % of GDP) of Low income?
Provide a short and direct response. 1.06. What is the difference between the highest and the lowest Rent(as % of GDP) in Morocco?
Keep it short and to the point. 8.25. What is the difference between the highest and the lowest Rent(as % of GDP) in Portugal?
Ensure brevity in your answer.  0.16. What is the difference between the highest and the lowest Rent(as % of GDP) in South Africa?
Offer a very short reply. 3.11. 